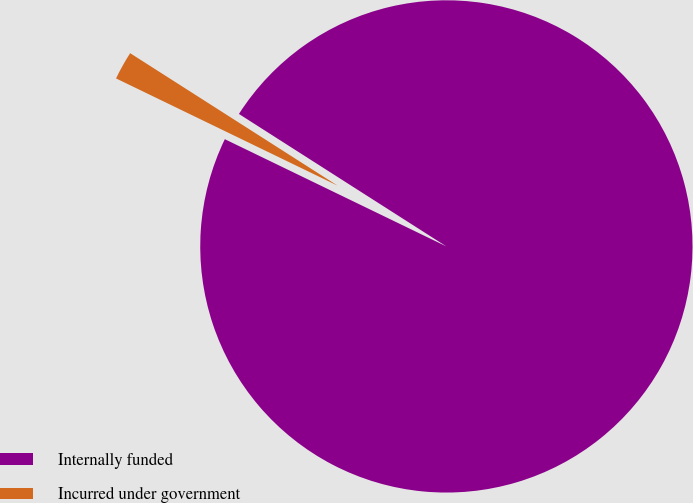<chart> <loc_0><loc_0><loc_500><loc_500><pie_chart><fcel>Internally funded<fcel>Incurred under government<nl><fcel>98.13%<fcel>1.87%<nl></chart> 